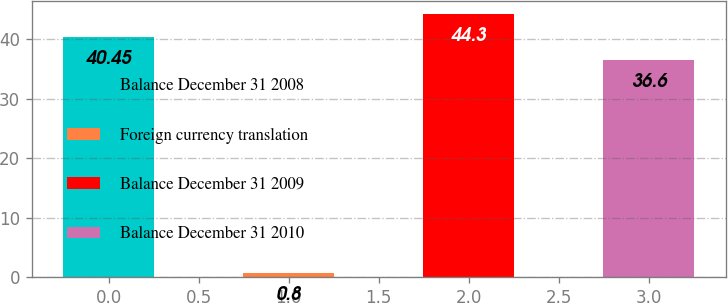<chart> <loc_0><loc_0><loc_500><loc_500><bar_chart><fcel>Balance December 31 2008<fcel>Foreign currency translation<fcel>Balance December 31 2009<fcel>Balance December 31 2010<nl><fcel>40.45<fcel>0.8<fcel>44.3<fcel>36.6<nl></chart> 